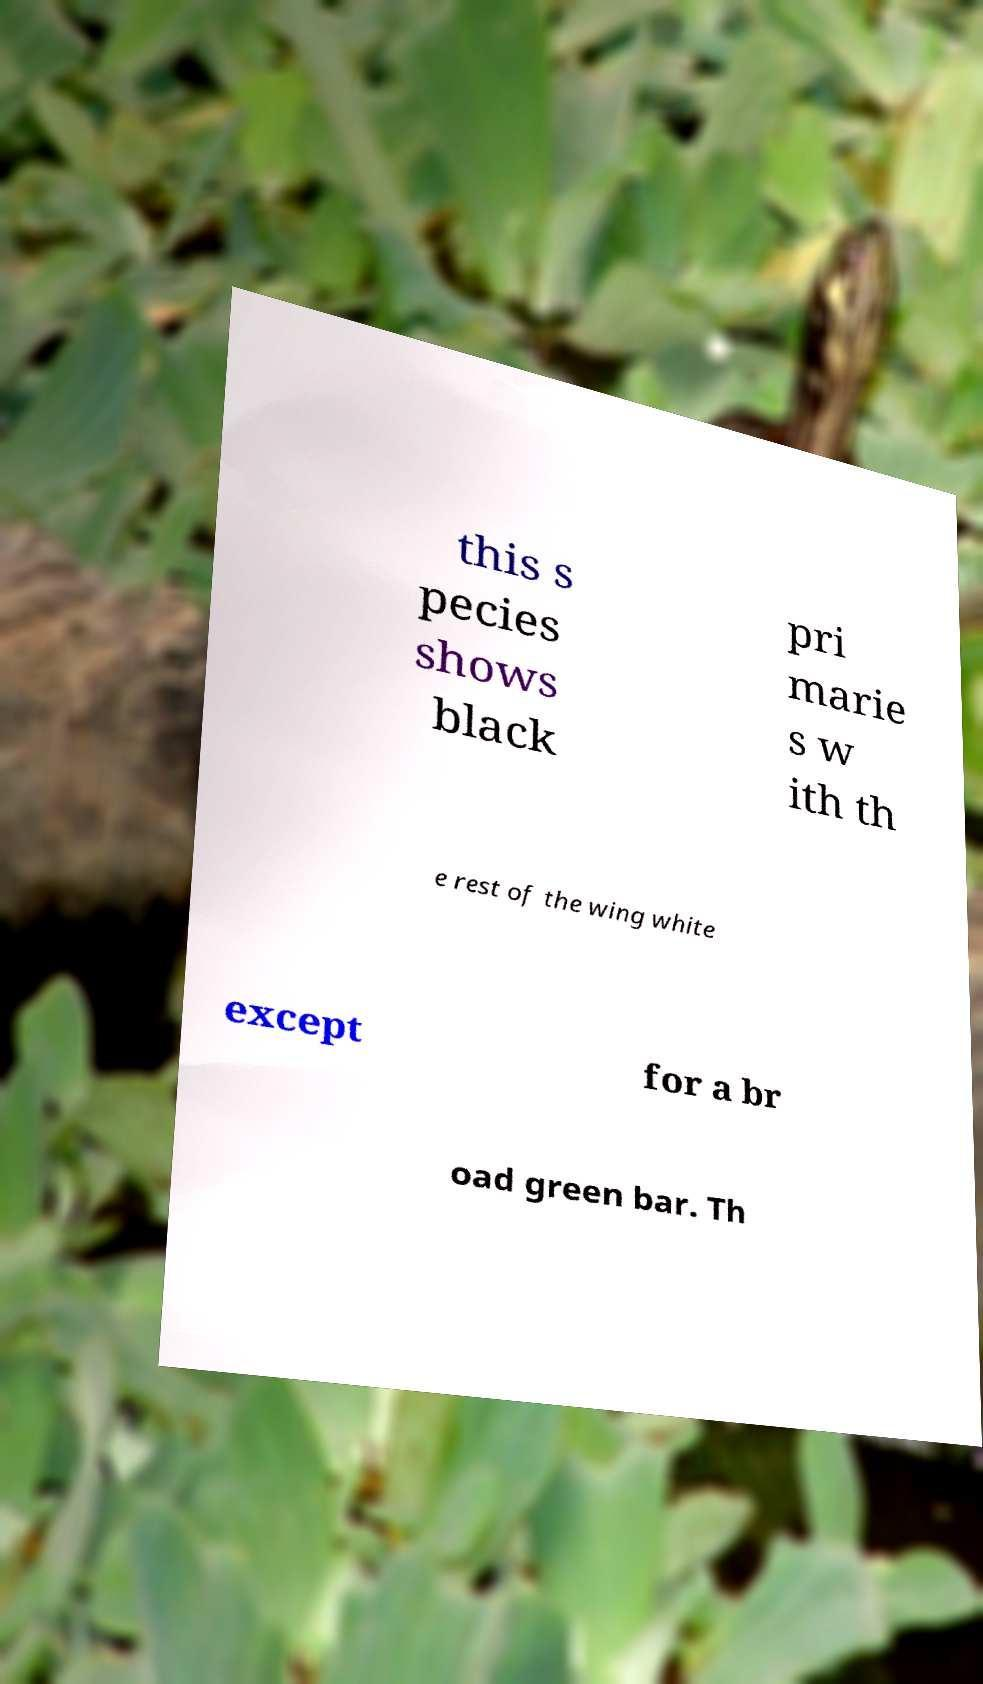I need the written content from this picture converted into text. Can you do that? this s pecies shows black pri marie s w ith th e rest of the wing white except for a br oad green bar. Th 